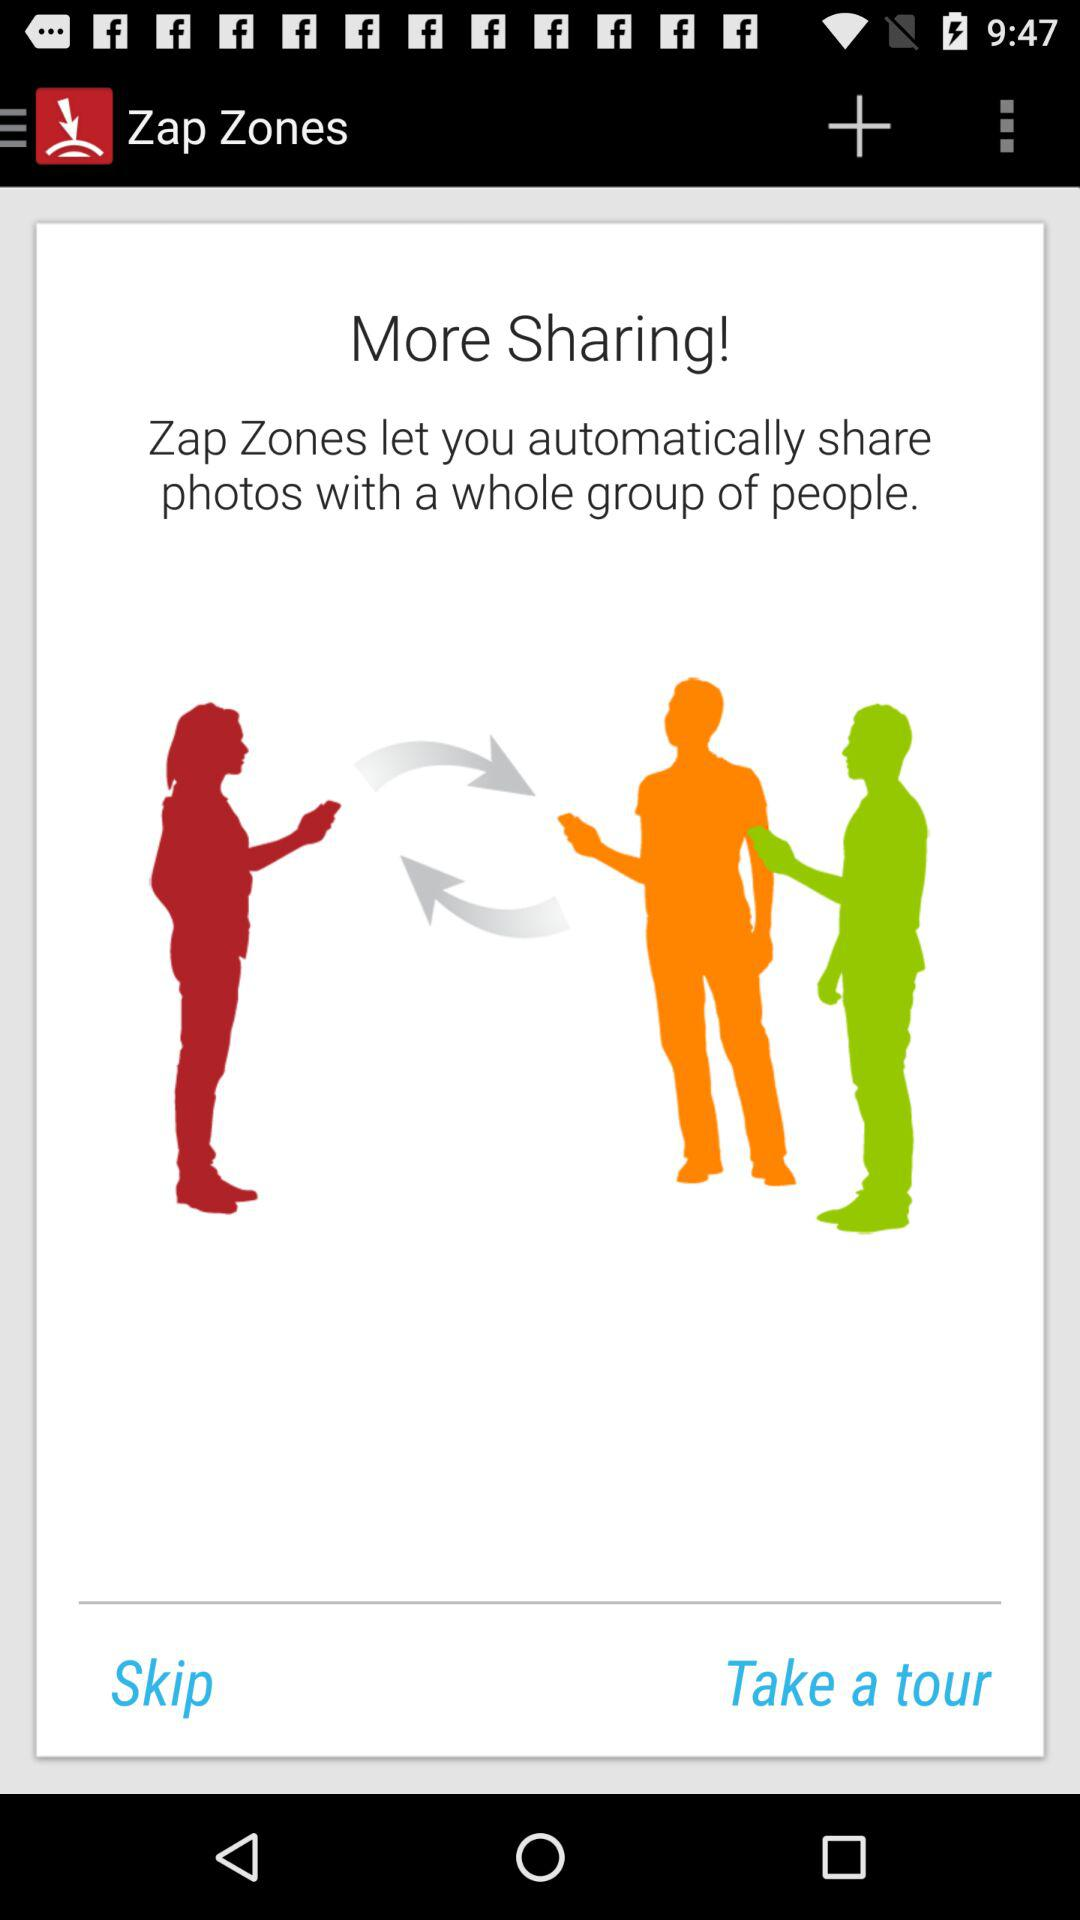What is the name of the application? The name of the application is "Zap Zones". 